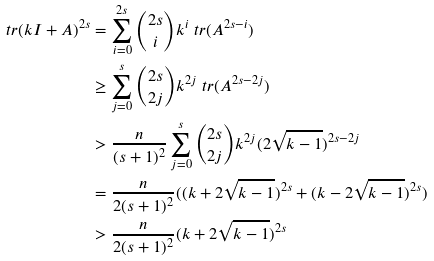Convert formula to latex. <formula><loc_0><loc_0><loc_500><loc_500>\ t r ( k I + A ) ^ { 2 s } & = \sum _ { i = 0 } ^ { 2 s } { 2 s \choose i } k ^ { i } \ t r ( A ^ { 2 s - i } ) \\ & \geq \sum _ { j = 0 } ^ { s } { 2 s \choose 2 j } k ^ { 2 j } \ t r ( A ^ { 2 s - 2 j } ) \\ & > \frac { n } { ( s + 1 ) ^ { 2 } } \sum _ { j = 0 } ^ { s } { 2 s \choose 2 j } k ^ { 2 j } ( 2 \sqrt { k - 1 } ) ^ { 2 s - 2 j } \\ & = \frac { n } { 2 ( s + 1 ) ^ { 2 } } ( ( k + 2 \sqrt { k - 1 } ) ^ { 2 s } + ( k - 2 \sqrt { k - 1 } ) ^ { 2 s } ) \\ & > \frac { n } { 2 ( s + 1 ) ^ { 2 } } ( k + 2 \sqrt { k - 1 } ) ^ { 2 s }</formula> 